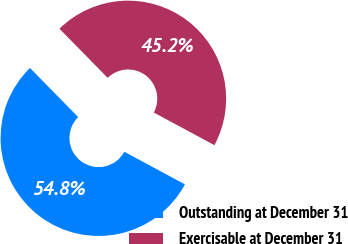Convert chart. <chart><loc_0><loc_0><loc_500><loc_500><pie_chart><fcel>Outstanding at December 31<fcel>Exercisable at December 31<nl><fcel>54.79%<fcel>45.21%<nl></chart> 